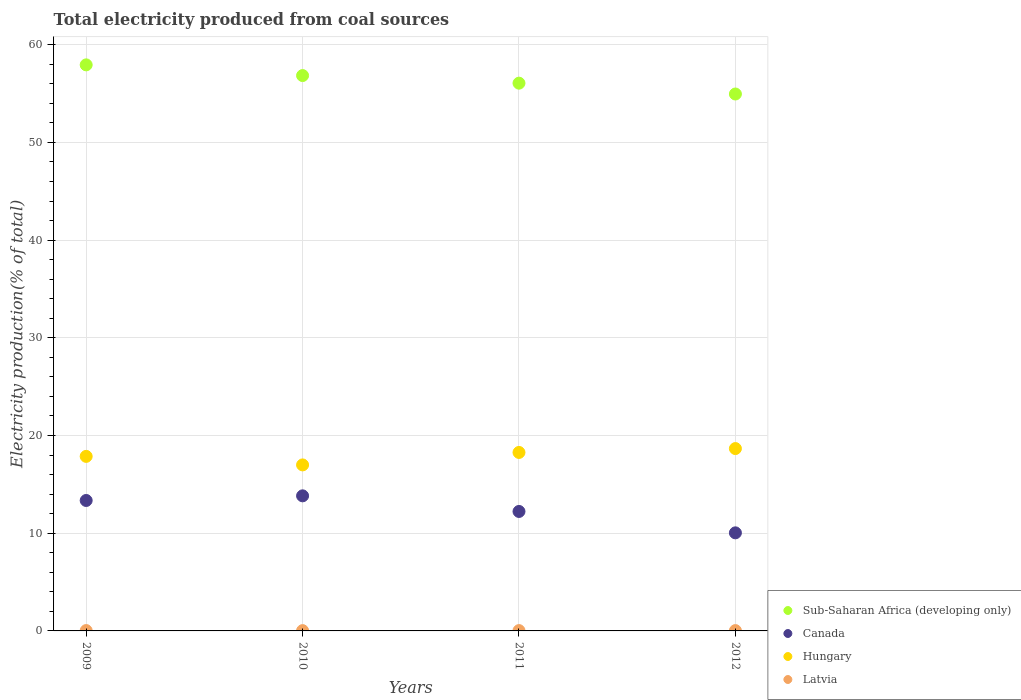How many different coloured dotlines are there?
Ensure brevity in your answer.  4. Is the number of dotlines equal to the number of legend labels?
Provide a succinct answer. Yes. What is the total electricity produced in Canada in 2009?
Make the answer very short. 13.35. Across all years, what is the maximum total electricity produced in Sub-Saharan Africa (developing only)?
Give a very brief answer. 57.94. Across all years, what is the minimum total electricity produced in Latvia?
Ensure brevity in your answer.  0.03. In which year was the total electricity produced in Canada maximum?
Ensure brevity in your answer.  2010. In which year was the total electricity produced in Hungary minimum?
Your response must be concise. 2010. What is the total total electricity produced in Canada in the graph?
Offer a very short reply. 49.44. What is the difference between the total electricity produced in Canada in 2009 and that in 2012?
Offer a terse response. 3.31. What is the difference between the total electricity produced in Latvia in 2012 and the total electricity produced in Sub-Saharan Africa (developing only) in 2010?
Your answer should be very brief. -56.81. What is the average total electricity produced in Sub-Saharan Africa (developing only) per year?
Ensure brevity in your answer.  56.45. In the year 2010, what is the difference between the total electricity produced in Latvia and total electricity produced in Canada?
Your answer should be very brief. -13.8. What is the ratio of the total electricity produced in Canada in 2010 to that in 2012?
Offer a very short reply. 1.38. What is the difference between the highest and the second highest total electricity produced in Hungary?
Keep it short and to the point. 0.4. What is the difference between the highest and the lowest total electricity produced in Canada?
Provide a succinct answer. 3.79. Is the sum of the total electricity produced in Hungary in 2009 and 2011 greater than the maximum total electricity produced in Latvia across all years?
Provide a succinct answer. Yes. Is it the case that in every year, the sum of the total electricity produced in Hungary and total electricity produced in Latvia  is greater than the sum of total electricity produced in Sub-Saharan Africa (developing only) and total electricity produced in Canada?
Your answer should be compact. No. How many dotlines are there?
Your response must be concise. 4. How many years are there in the graph?
Make the answer very short. 4. What is the difference between two consecutive major ticks on the Y-axis?
Give a very brief answer. 10. Are the values on the major ticks of Y-axis written in scientific E-notation?
Provide a succinct answer. No. Does the graph contain grids?
Keep it short and to the point. Yes. Where does the legend appear in the graph?
Your response must be concise. Bottom right. How many legend labels are there?
Your answer should be compact. 4. What is the title of the graph?
Provide a short and direct response. Total electricity produced from coal sources. Does "Denmark" appear as one of the legend labels in the graph?
Offer a terse response. No. What is the label or title of the X-axis?
Provide a succinct answer. Years. What is the Electricity production(% of total) of Sub-Saharan Africa (developing only) in 2009?
Your answer should be compact. 57.94. What is the Electricity production(% of total) in Canada in 2009?
Offer a terse response. 13.35. What is the Electricity production(% of total) in Hungary in 2009?
Ensure brevity in your answer.  17.87. What is the Electricity production(% of total) of Latvia in 2009?
Ensure brevity in your answer.  0.04. What is the Electricity production(% of total) in Sub-Saharan Africa (developing only) in 2010?
Ensure brevity in your answer.  56.84. What is the Electricity production(% of total) in Canada in 2010?
Make the answer very short. 13.83. What is the Electricity production(% of total) in Hungary in 2010?
Your response must be concise. 16.99. What is the Electricity production(% of total) in Latvia in 2010?
Provide a short and direct response. 0.03. What is the Electricity production(% of total) of Sub-Saharan Africa (developing only) in 2011?
Your response must be concise. 56.06. What is the Electricity production(% of total) of Canada in 2011?
Offer a terse response. 12.23. What is the Electricity production(% of total) in Hungary in 2011?
Your answer should be compact. 18.27. What is the Electricity production(% of total) of Latvia in 2011?
Provide a succinct answer. 0.03. What is the Electricity production(% of total) in Sub-Saharan Africa (developing only) in 2012?
Offer a terse response. 54.95. What is the Electricity production(% of total) in Canada in 2012?
Offer a terse response. 10.04. What is the Electricity production(% of total) of Hungary in 2012?
Your answer should be compact. 18.66. What is the Electricity production(% of total) in Latvia in 2012?
Give a very brief answer. 0.03. Across all years, what is the maximum Electricity production(% of total) of Sub-Saharan Africa (developing only)?
Your answer should be very brief. 57.94. Across all years, what is the maximum Electricity production(% of total) in Canada?
Offer a terse response. 13.83. Across all years, what is the maximum Electricity production(% of total) in Hungary?
Make the answer very short. 18.66. Across all years, what is the maximum Electricity production(% of total) of Latvia?
Your answer should be compact. 0.04. Across all years, what is the minimum Electricity production(% of total) in Sub-Saharan Africa (developing only)?
Make the answer very short. 54.95. Across all years, what is the minimum Electricity production(% of total) in Canada?
Ensure brevity in your answer.  10.04. Across all years, what is the minimum Electricity production(% of total) in Hungary?
Keep it short and to the point. 16.99. Across all years, what is the minimum Electricity production(% of total) in Latvia?
Provide a succinct answer. 0.03. What is the total Electricity production(% of total) in Sub-Saharan Africa (developing only) in the graph?
Provide a short and direct response. 225.8. What is the total Electricity production(% of total) of Canada in the graph?
Offer a terse response. 49.44. What is the total Electricity production(% of total) of Hungary in the graph?
Offer a very short reply. 71.79. What is the total Electricity production(% of total) of Latvia in the graph?
Your response must be concise. 0.13. What is the difference between the Electricity production(% of total) of Sub-Saharan Africa (developing only) in 2009 and that in 2010?
Your answer should be compact. 1.1. What is the difference between the Electricity production(% of total) in Canada in 2009 and that in 2010?
Your response must be concise. -0.47. What is the difference between the Electricity production(% of total) of Hungary in 2009 and that in 2010?
Offer a very short reply. 0.87. What is the difference between the Electricity production(% of total) in Latvia in 2009 and that in 2010?
Offer a terse response. 0.01. What is the difference between the Electricity production(% of total) in Sub-Saharan Africa (developing only) in 2009 and that in 2011?
Provide a succinct answer. 1.87. What is the difference between the Electricity production(% of total) of Canada in 2009 and that in 2011?
Offer a terse response. 1.12. What is the difference between the Electricity production(% of total) in Hungary in 2009 and that in 2011?
Offer a terse response. -0.4. What is the difference between the Electricity production(% of total) of Latvia in 2009 and that in 2011?
Provide a succinct answer. 0. What is the difference between the Electricity production(% of total) in Sub-Saharan Africa (developing only) in 2009 and that in 2012?
Ensure brevity in your answer.  2.98. What is the difference between the Electricity production(% of total) of Canada in 2009 and that in 2012?
Make the answer very short. 3.31. What is the difference between the Electricity production(% of total) in Hungary in 2009 and that in 2012?
Your answer should be very brief. -0.8. What is the difference between the Electricity production(% of total) of Latvia in 2009 and that in 2012?
Offer a terse response. 0. What is the difference between the Electricity production(% of total) of Sub-Saharan Africa (developing only) in 2010 and that in 2011?
Offer a terse response. 0.78. What is the difference between the Electricity production(% of total) of Canada in 2010 and that in 2011?
Offer a very short reply. 1.6. What is the difference between the Electricity production(% of total) of Hungary in 2010 and that in 2011?
Your answer should be compact. -1.28. What is the difference between the Electricity production(% of total) of Latvia in 2010 and that in 2011?
Give a very brief answer. -0. What is the difference between the Electricity production(% of total) in Sub-Saharan Africa (developing only) in 2010 and that in 2012?
Offer a terse response. 1.89. What is the difference between the Electricity production(% of total) of Canada in 2010 and that in 2012?
Offer a terse response. 3.79. What is the difference between the Electricity production(% of total) of Hungary in 2010 and that in 2012?
Your answer should be very brief. -1.67. What is the difference between the Electricity production(% of total) in Latvia in 2010 and that in 2012?
Your answer should be very brief. -0. What is the difference between the Electricity production(% of total) in Sub-Saharan Africa (developing only) in 2011 and that in 2012?
Your response must be concise. 1.11. What is the difference between the Electricity production(% of total) in Canada in 2011 and that in 2012?
Your response must be concise. 2.19. What is the difference between the Electricity production(% of total) of Hungary in 2011 and that in 2012?
Keep it short and to the point. -0.4. What is the difference between the Electricity production(% of total) of Sub-Saharan Africa (developing only) in 2009 and the Electricity production(% of total) of Canada in 2010?
Offer a very short reply. 44.11. What is the difference between the Electricity production(% of total) of Sub-Saharan Africa (developing only) in 2009 and the Electricity production(% of total) of Hungary in 2010?
Ensure brevity in your answer.  40.95. What is the difference between the Electricity production(% of total) in Sub-Saharan Africa (developing only) in 2009 and the Electricity production(% of total) in Latvia in 2010?
Provide a short and direct response. 57.91. What is the difference between the Electricity production(% of total) of Canada in 2009 and the Electricity production(% of total) of Hungary in 2010?
Your answer should be compact. -3.64. What is the difference between the Electricity production(% of total) of Canada in 2009 and the Electricity production(% of total) of Latvia in 2010?
Your response must be concise. 13.32. What is the difference between the Electricity production(% of total) of Hungary in 2009 and the Electricity production(% of total) of Latvia in 2010?
Make the answer very short. 17.83. What is the difference between the Electricity production(% of total) of Sub-Saharan Africa (developing only) in 2009 and the Electricity production(% of total) of Canada in 2011?
Keep it short and to the point. 45.71. What is the difference between the Electricity production(% of total) of Sub-Saharan Africa (developing only) in 2009 and the Electricity production(% of total) of Hungary in 2011?
Keep it short and to the point. 39.67. What is the difference between the Electricity production(% of total) in Sub-Saharan Africa (developing only) in 2009 and the Electricity production(% of total) in Latvia in 2011?
Your answer should be compact. 57.9. What is the difference between the Electricity production(% of total) of Canada in 2009 and the Electricity production(% of total) of Hungary in 2011?
Provide a short and direct response. -4.92. What is the difference between the Electricity production(% of total) in Canada in 2009 and the Electricity production(% of total) in Latvia in 2011?
Your response must be concise. 13.32. What is the difference between the Electricity production(% of total) of Hungary in 2009 and the Electricity production(% of total) of Latvia in 2011?
Provide a short and direct response. 17.83. What is the difference between the Electricity production(% of total) in Sub-Saharan Africa (developing only) in 2009 and the Electricity production(% of total) in Canada in 2012?
Offer a very short reply. 47.9. What is the difference between the Electricity production(% of total) in Sub-Saharan Africa (developing only) in 2009 and the Electricity production(% of total) in Hungary in 2012?
Offer a terse response. 39.27. What is the difference between the Electricity production(% of total) of Sub-Saharan Africa (developing only) in 2009 and the Electricity production(% of total) of Latvia in 2012?
Ensure brevity in your answer.  57.9. What is the difference between the Electricity production(% of total) of Canada in 2009 and the Electricity production(% of total) of Hungary in 2012?
Offer a terse response. -5.31. What is the difference between the Electricity production(% of total) of Canada in 2009 and the Electricity production(% of total) of Latvia in 2012?
Keep it short and to the point. 13.32. What is the difference between the Electricity production(% of total) of Hungary in 2009 and the Electricity production(% of total) of Latvia in 2012?
Provide a short and direct response. 17.83. What is the difference between the Electricity production(% of total) in Sub-Saharan Africa (developing only) in 2010 and the Electricity production(% of total) in Canada in 2011?
Make the answer very short. 44.61. What is the difference between the Electricity production(% of total) of Sub-Saharan Africa (developing only) in 2010 and the Electricity production(% of total) of Hungary in 2011?
Ensure brevity in your answer.  38.58. What is the difference between the Electricity production(% of total) of Sub-Saharan Africa (developing only) in 2010 and the Electricity production(% of total) of Latvia in 2011?
Provide a short and direct response. 56.81. What is the difference between the Electricity production(% of total) in Canada in 2010 and the Electricity production(% of total) in Hungary in 2011?
Your answer should be compact. -4.44. What is the difference between the Electricity production(% of total) of Canada in 2010 and the Electricity production(% of total) of Latvia in 2011?
Your answer should be very brief. 13.79. What is the difference between the Electricity production(% of total) in Hungary in 2010 and the Electricity production(% of total) in Latvia in 2011?
Provide a succinct answer. 16.96. What is the difference between the Electricity production(% of total) of Sub-Saharan Africa (developing only) in 2010 and the Electricity production(% of total) of Canada in 2012?
Ensure brevity in your answer.  46.8. What is the difference between the Electricity production(% of total) of Sub-Saharan Africa (developing only) in 2010 and the Electricity production(% of total) of Hungary in 2012?
Make the answer very short. 38.18. What is the difference between the Electricity production(% of total) in Sub-Saharan Africa (developing only) in 2010 and the Electricity production(% of total) in Latvia in 2012?
Give a very brief answer. 56.81. What is the difference between the Electricity production(% of total) in Canada in 2010 and the Electricity production(% of total) in Hungary in 2012?
Provide a short and direct response. -4.84. What is the difference between the Electricity production(% of total) of Canada in 2010 and the Electricity production(% of total) of Latvia in 2012?
Give a very brief answer. 13.79. What is the difference between the Electricity production(% of total) in Hungary in 2010 and the Electricity production(% of total) in Latvia in 2012?
Your response must be concise. 16.96. What is the difference between the Electricity production(% of total) in Sub-Saharan Africa (developing only) in 2011 and the Electricity production(% of total) in Canada in 2012?
Provide a short and direct response. 46.03. What is the difference between the Electricity production(% of total) of Sub-Saharan Africa (developing only) in 2011 and the Electricity production(% of total) of Hungary in 2012?
Make the answer very short. 37.4. What is the difference between the Electricity production(% of total) of Sub-Saharan Africa (developing only) in 2011 and the Electricity production(% of total) of Latvia in 2012?
Provide a short and direct response. 56.03. What is the difference between the Electricity production(% of total) of Canada in 2011 and the Electricity production(% of total) of Hungary in 2012?
Offer a very short reply. -6.44. What is the difference between the Electricity production(% of total) in Canada in 2011 and the Electricity production(% of total) in Latvia in 2012?
Offer a very short reply. 12.2. What is the difference between the Electricity production(% of total) of Hungary in 2011 and the Electricity production(% of total) of Latvia in 2012?
Keep it short and to the point. 18.23. What is the average Electricity production(% of total) in Sub-Saharan Africa (developing only) per year?
Give a very brief answer. 56.45. What is the average Electricity production(% of total) in Canada per year?
Provide a succinct answer. 12.36. What is the average Electricity production(% of total) in Hungary per year?
Your response must be concise. 17.95. What is the average Electricity production(% of total) of Latvia per year?
Your answer should be very brief. 0.03. In the year 2009, what is the difference between the Electricity production(% of total) in Sub-Saharan Africa (developing only) and Electricity production(% of total) in Canada?
Ensure brevity in your answer.  44.59. In the year 2009, what is the difference between the Electricity production(% of total) of Sub-Saharan Africa (developing only) and Electricity production(% of total) of Hungary?
Provide a short and direct response. 40.07. In the year 2009, what is the difference between the Electricity production(% of total) of Sub-Saharan Africa (developing only) and Electricity production(% of total) of Latvia?
Your answer should be compact. 57.9. In the year 2009, what is the difference between the Electricity production(% of total) of Canada and Electricity production(% of total) of Hungary?
Make the answer very short. -4.51. In the year 2009, what is the difference between the Electricity production(% of total) in Canada and Electricity production(% of total) in Latvia?
Ensure brevity in your answer.  13.31. In the year 2009, what is the difference between the Electricity production(% of total) in Hungary and Electricity production(% of total) in Latvia?
Keep it short and to the point. 17.83. In the year 2010, what is the difference between the Electricity production(% of total) of Sub-Saharan Africa (developing only) and Electricity production(% of total) of Canada?
Give a very brief answer. 43.02. In the year 2010, what is the difference between the Electricity production(% of total) in Sub-Saharan Africa (developing only) and Electricity production(% of total) in Hungary?
Your answer should be compact. 39.85. In the year 2010, what is the difference between the Electricity production(% of total) of Sub-Saharan Africa (developing only) and Electricity production(% of total) of Latvia?
Provide a succinct answer. 56.81. In the year 2010, what is the difference between the Electricity production(% of total) of Canada and Electricity production(% of total) of Hungary?
Ensure brevity in your answer.  -3.17. In the year 2010, what is the difference between the Electricity production(% of total) in Canada and Electricity production(% of total) in Latvia?
Make the answer very short. 13.8. In the year 2010, what is the difference between the Electricity production(% of total) of Hungary and Electricity production(% of total) of Latvia?
Offer a very short reply. 16.96. In the year 2011, what is the difference between the Electricity production(% of total) in Sub-Saharan Africa (developing only) and Electricity production(% of total) in Canada?
Provide a short and direct response. 43.84. In the year 2011, what is the difference between the Electricity production(% of total) in Sub-Saharan Africa (developing only) and Electricity production(% of total) in Hungary?
Your answer should be compact. 37.8. In the year 2011, what is the difference between the Electricity production(% of total) in Sub-Saharan Africa (developing only) and Electricity production(% of total) in Latvia?
Your answer should be compact. 56.03. In the year 2011, what is the difference between the Electricity production(% of total) in Canada and Electricity production(% of total) in Hungary?
Offer a terse response. -6.04. In the year 2011, what is the difference between the Electricity production(% of total) of Canada and Electricity production(% of total) of Latvia?
Provide a short and direct response. 12.19. In the year 2011, what is the difference between the Electricity production(% of total) in Hungary and Electricity production(% of total) in Latvia?
Ensure brevity in your answer.  18.23. In the year 2012, what is the difference between the Electricity production(% of total) of Sub-Saharan Africa (developing only) and Electricity production(% of total) of Canada?
Your response must be concise. 44.92. In the year 2012, what is the difference between the Electricity production(% of total) in Sub-Saharan Africa (developing only) and Electricity production(% of total) in Hungary?
Make the answer very short. 36.29. In the year 2012, what is the difference between the Electricity production(% of total) of Sub-Saharan Africa (developing only) and Electricity production(% of total) of Latvia?
Provide a succinct answer. 54.92. In the year 2012, what is the difference between the Electricity production(% of total) of Canada and Electricity production(% of total) of Hungary?
Offer a terse response. -8.63. In the year 2012, what is the difference between the Electricity production(% of total) of Canada and Electricity production(% of total) of Latvia?
Offer a terse response. 10.01. In the year 2012, what is the difference between the Electricity production(% of total) of Hungary and Electricity production(% of total) of Latvia?
Provide a succinct answer. 18.63. What is the ratio of the Electricity production(% of total) in Sub-Saharan Africa (developing only) in 2009 to that in 2010?
Your response must be concise. 1.02. What is the ratio of the Electricity production(% of total) in Canada in 2009 to that in 2010?
Your response must be concise. 0.97. What is the ratio of the Electricity production(% of total) in Hungary in 2009 to that in 2010?
Keep it short and to the point. 1.05. What is the ratio of the Electricity production(% of total) in Latvia in 2009 to that in 2010?
Your response must be concise. 1.19. What is the ratio of the Electricity production(% of total) of Sub-Saharan Africa (developing only) in 2009 to that in 2011?
Give a very brief answer. 1.03. What is the ratio of the Electricity production(% of total) in Canada in 2009 to that in 2011?
Keep it short and to the point. 1.09. What is the ratio of the Electricity production(% of total) of Latvia in 2009 to that in 2011?
Make the answer very short. 1.09. What is the ratio of the Electricity production(% of total) of Sub-Saharan Africa (developing only) in 2009 to that in 2012?
Offer a terse response. 1.05. What is the ratio of the Electricity production(% of total) in Canada in 2009 to that in 2012?
Your answer should be very brief. 1.33. What is the ratio of the Electricity production(% of total) in Hungary in 2009 to that in 2012?
Offer a terse response. 0.96. What is the ratio of the Electricity production(% of total) of Latvia in 2009 to that in 2012?
Make the answer very short. 1.11. What is the ratio of the Electricity production(% of total) in Sub-Saharan Africa (developing only) in 2010 to that in 2011?
Offer a terse response. 1.01. What is the ratio of the Electricity production(% of total) of Canada in 2010 to that in 2011?
Offer a very short reply. 1.13. What is the ratio of the Electricity production(% of total) in Hungary in 2010 to that in 2011?
Your answer should be very brief. 0.93. What is the ratio of the Electricity production(% of total) in Latvia in 2010 to that in 2011?
Offer a terse response. 0.92. What is the ratio of the Electricity production(% of total) of Sub-Saharan Africa (developing only) in 2010 to that in 2012?
Provide a short and direct response. 1.03. What is the ratio of the Electricity production(% of total) of Canada in 2010 to that in 2012?
Offer a terse response. 1.38. What is the ratio of the Electricity production(% of total) in Hungary in 2010 to that in 2012?
Offer a terse response. 0.91. What is the ratio of the Electricity production(% of total) in Latvia in 2010 to that in 2012?
Keep it short and to the point. 0.93. What is the ratio of the Electricity production(% of total) of Sub-Saharan Africa (developing only) in 2011 to that in 2012?
Give a very brief answer. 1.02. What is the ratio of the Electricity production(% of total) of Canada in 2011 to that in 2012?
Your answer should be very brief. 1.22. What is the ratio of the Electricity production(% of total) of Hungary in 2011 to that in 2012?
Provide a succinct answer. 0.98. What is the difference between the highest and the second highest Electricity production(% of total) of Sub-Saharan Africa (developing only)?
Provide a short and direct response. 1.1. What is the difference between the highest and the second highest Electricity production(% of total) of Canada?
Offer a very short reply. 0.47. What is the difference between the highest and the second highest Electricity production(% of total) in Hungary?
Provide a short and direct response. 0.4. What is the difference between the highest and the second highest Electricity production(% of total) of Latvia?
Provide a succinct answer. 0. What is the difference between the highest and the lowest Electricity production(% of total) of Sub-Saharan Africa (developing only)?
Offer a very short reply. 2.98. What is the difference between the highest and the lowest Electricity production(% of total) in Canada?
Make the answer very short. 3.79. What is the difference between the highest and the lowest Electricity production(% of total) of Hungary?
Your answer should be compact. 1.67. What is the difference between the highest and the lowest Electricity production(% of total) in Latvia?
Provide a succinct answer. 0.01. 